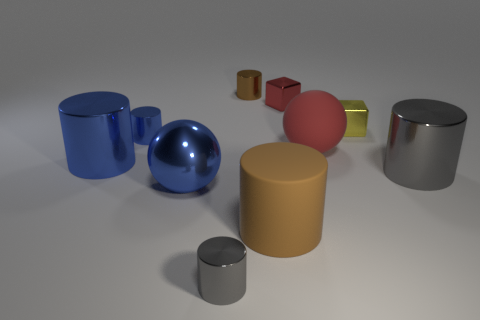Subtract all brown shiny cylinders. How many cylinders are left? 5 Subtract all blue cylinders. How many cylinders are left? 4 Subtract 2 cylinders. How many cylinders are left? 4 Subtract all gray balls. Subtract all green cylinders. How many balls are left? 2 Subtract all gray blocks. How many red spheres are left? 1 Add 8 tiny blue metallic cylinders. How many tiny blue metallic cylinders are left? 9 Add 10 big yellow rubber cylinders. How many big yellow rubber cylinders exist? 10 Subtract 0 green balls. How many objects are left? 10 Subtract all cubes. How many objects are left? 8 Subtract all big matte spheres. Subtract all big red rubber things. How many objects are left? 8 